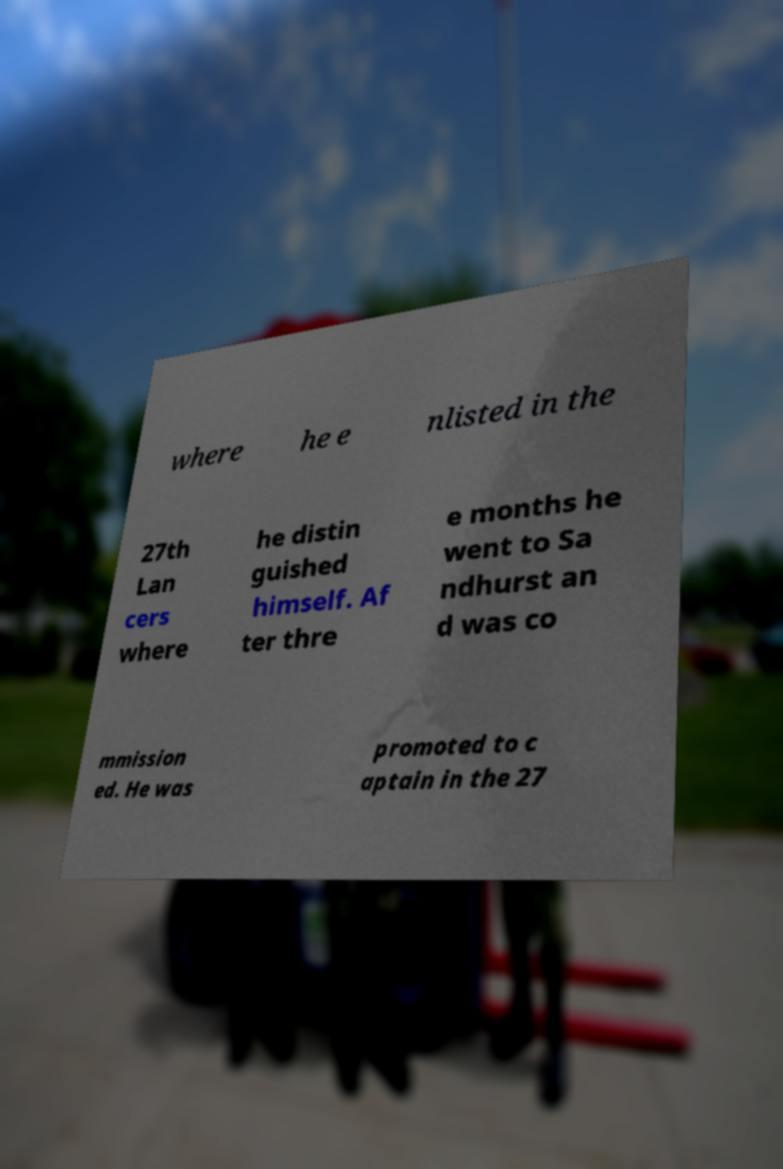What messages or text are displayed in this image? I need them in a readable, typed format. where he e nlisted in the 27th Lan cers where he distin guished himself. Af ter thre e months he went to Sa ndhurst an d was co mmission ed. He was promoted to c aptain in the 27 